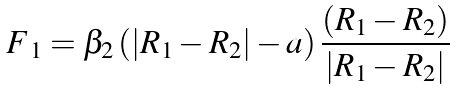Convert formula to latex. <formula><loc_0><loc_0><loc_500><loc_500>\boldsymbol F _ { 1 } = \beta _ { 2 } \left ( \left | \boldsymbol R _ { 1 } - \boldsymbol R _ { 2 } \right | - a \right ) \frac { ( \boldsymbol R _ { 1 } - \boldsymbol R _ { 2 } ) } { | \boldsymbol R _ { 1 } - \boldsymbol R _ { 2 } | }</formula> 